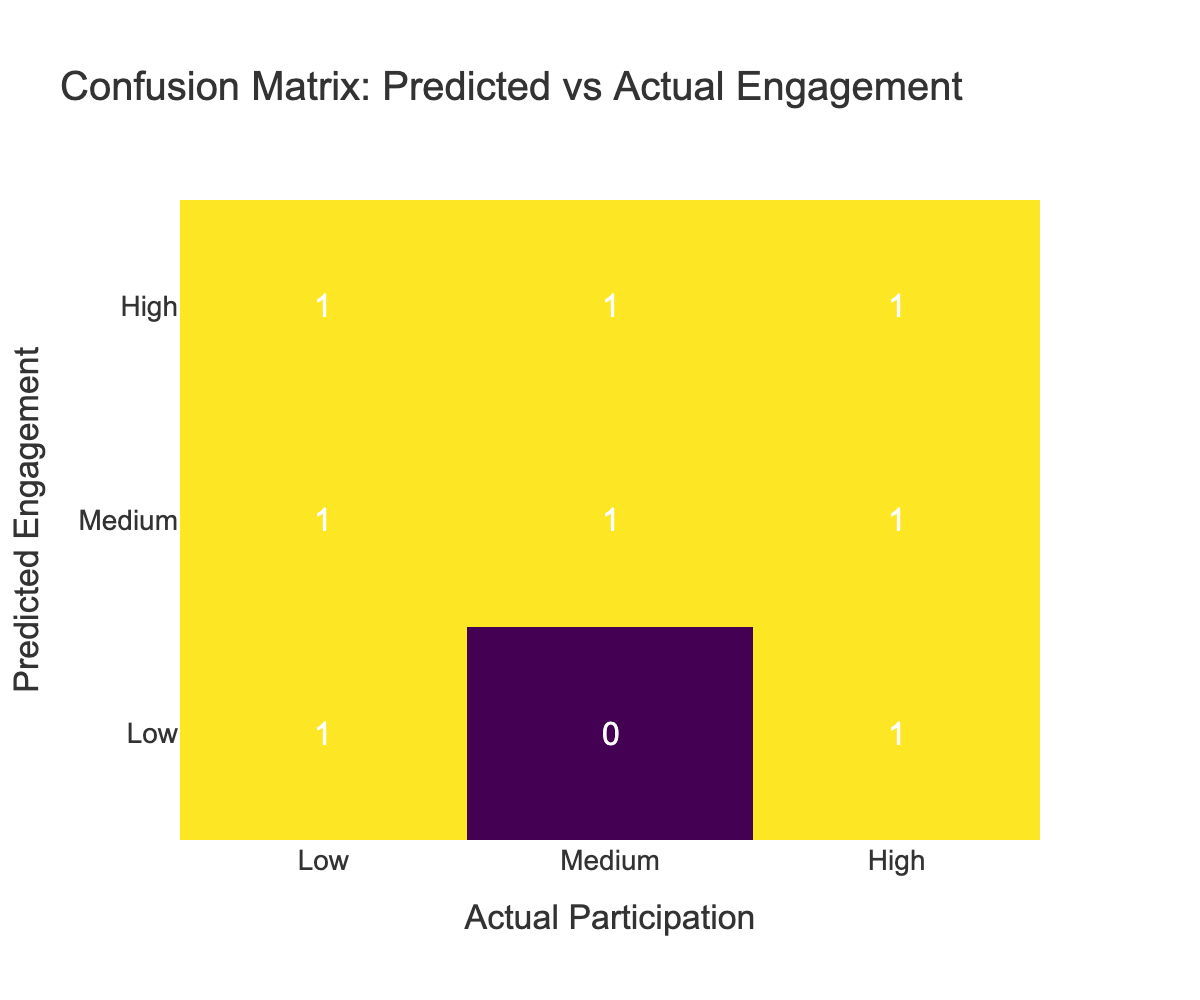What is the count of True Positives in the table? The True Positive count corresponds to instances where the predicted engagement was High, and the actual participation was also High. Scanning the table, we see one instance labeled as True Positive.
Answer: 1 How many instances were classified as False Negatives? False Negatives are instances where the predicted engagement was High but the actual participation was Low. Referring to the table, there are two instances labeled as False Negative.
Answer: 2 What is the total number of instances where Actual Participation was High? To find this, we need to count all instances in the Actual Participation column where the engagement level is High. There are three instances that show High participation, counted from the table.
Answer: 3 Is there any instance where the predicted engagement is Low but the actual participation is Medium? By reviewing the table, we find that there are no instances categorized with Low predicted engagement and Medium actual participation. Hence, the answer is no.
Answer: No What is the difference between the counts of True Negatives and False Positives? True Negatives occur when the engagement was predicted as Low, and participation was also Low; there are two instances of this. False Positives are where the predicted engagement was Medium, and the actual was High; there are also two instances of this. The difference is 2 (True Negatives) - 2 (False Positives) = 0.
Answer: 0 What is the percentage of False Positives in relation to the total number of predictions? There are four False Positives in total (from two instances where Medium was predicted for a High actual and two where Low was predicted for a High actual). The total number of predictions observed in the table is six. Thus, the percentage of False Positives is (4/6)*100 which equals approximately 66.67%.
Answer: 66.67 How many unique categories are represented in the Predicted Engagement? The Predicted Engagement column includes three unique categories: Low, Medium, and High. Counting these shows there are three distinct categories represented.
Answer: 3 What is the ratio of True Positives to False Negatives? True Positives sum to 1, and False Negatives sum to 2. The ratio of True Positives to False Negatives is thus 1:2 when simplified. This indicates that for every True Positive, there are two False Negatives.
Answer: 1:2 